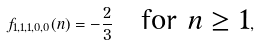Convert formula to latex. <formula><loc_0><loc_0><loc_500><loc_500>f _ { 1 , 1 , 1 , 0 , 0 } ( n ) = - \frac { 2 } 3 \quad \text {for $n\geq 1$} ,</formula> 